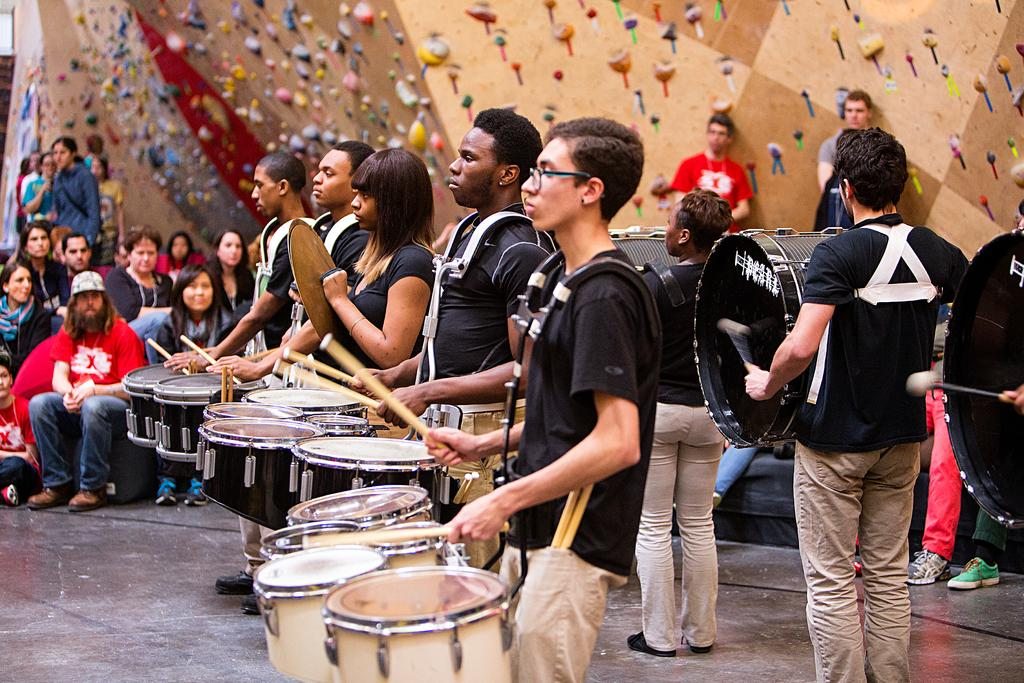What are the performers doing in the image? The performers are playing drums in the image. What can be observed about the audience in the image? There are people seated and watching the performance. How many beds are visible in the image? There are no beds present in the image. What type of suggestion can be made to improve the performance in the image? The provided facts do not allow for a suggestion to be made about improving the performance, as we are only describing what is visible in the image. 